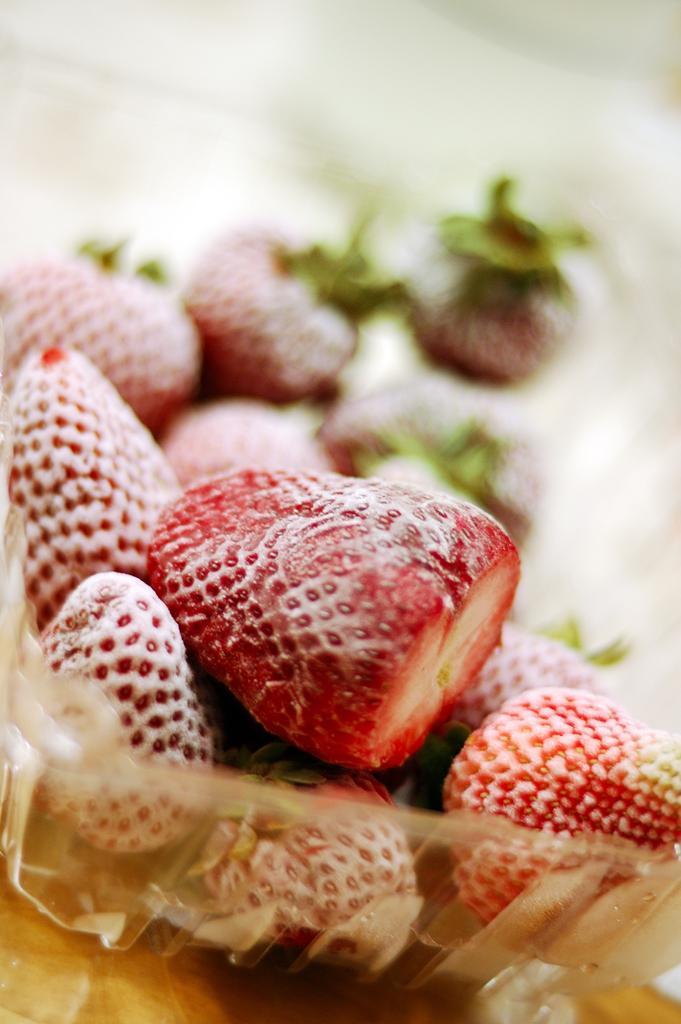Describe this image in one or two sentences. In this image there are a few cherries in a plastic bowl. 